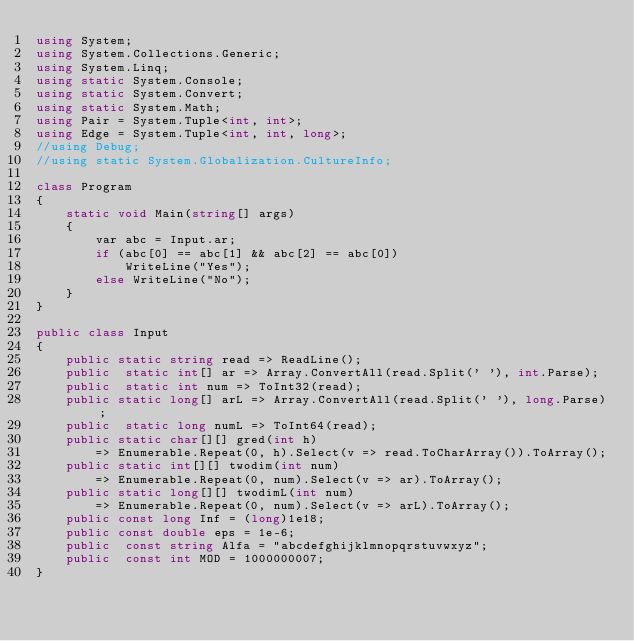<code> <loc_0><loc_0><loc_500><loc_500><_C#_>using System;
using System.Collections.Generic;
using System.Linq;
using static System.Console;
using static System.Convert;
using static System.Math;
using Pair = System.Tuple<int, int>;
using Edge = System.Tuple<int, int, long>;
//using Debug;
//using static System.Globalization.CultureInfo;

class Program
{
    static void Main(string[] args)
    {
        var abc = Input.ar;
        if (abc[0] == abc[1] && abc[2] == abc[0])
            WriteLine("Yes");
        else WriteLine("No");
    }
}

public class Input
{
    public static string read => ReadLine();
    public  static int[] ar => Array.ConvertAll(read.Split(' '), int.Parse);
    public  static int num => ToInt32(read);
    public static long[] arL => Array.ConvertAll(read.Split(' '), long.Parse);
    public  static long numL => ToInt64(read);
    public static char[][] gred(int h) 
        => Enumerable.Repeat(0, h).Select(v => read.ToCharArray()).ToArray();
    public static int[][] twodim(int num)
        => Enumerable.Repeat(0, num).Select(v => ar).ToArray();
    public static long[][] twodimL(int num)
        => Enumerable.Repeat(0, num).Select(v => arL).ToArray();
    public const long Inf = (long)1e18;
    public const double eps = 1e-6;
    public  const string Alfa = "abcdefghijklmnopqrstuvwxyz";
    public  const int MOD = 1000000007;
}
</code> 